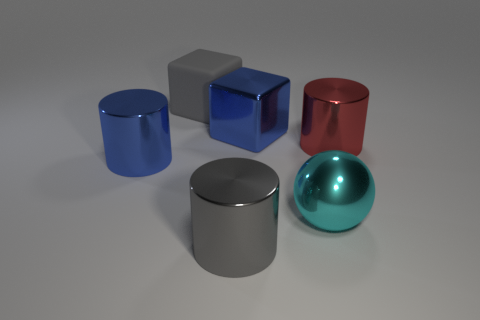Add 1 gray metallic things. How many objects exist? 7 Subtract all balls. How many objects are left? 5 Add 4 big gray metallic cylinders. How many big gray metallic cylinders are left? 5 Add 1 big gray metallic things. How many big gray metallic things exist? 2 Subtract 0 yellow blocks. How many objects are left? 6 Subtract all big gray cylinders. Subtract all large red metal spheres. How many objects are left? 5 